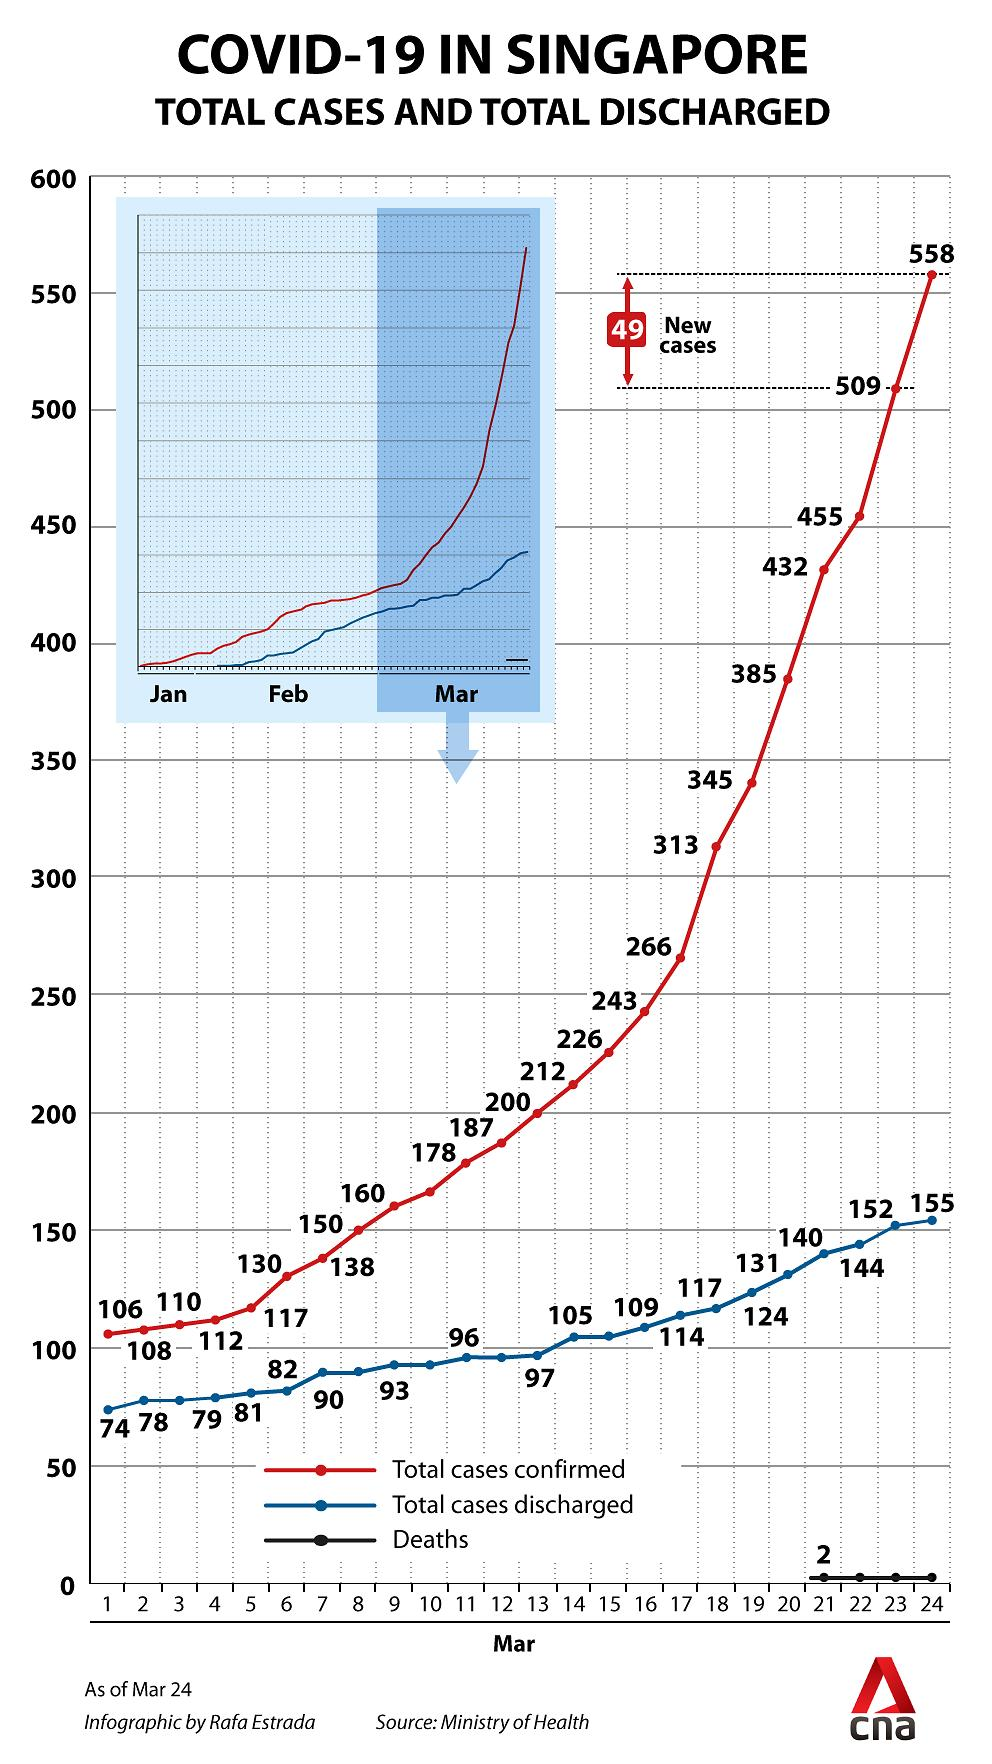Identify some key points in this picture. As of March 21, the total number of COVID-19 deaths reported in Singapore is 2,000. As of March 21, the total number of Covid patients who were discharged in Singapore was 140. As of March 6th, the total number of confirmed COVID-19 cases reported in Singapore is 130. On March 24, there were 49 new confirmed COVID-19 cases reported in Singapore. As of March 23, the total number of confirmed COVID-19 cases reported in Singapore is 509. 